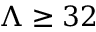<formula> <loc_0><loc_0><loc_500><loc_500>\Lambda \geq 3 2</formula> 